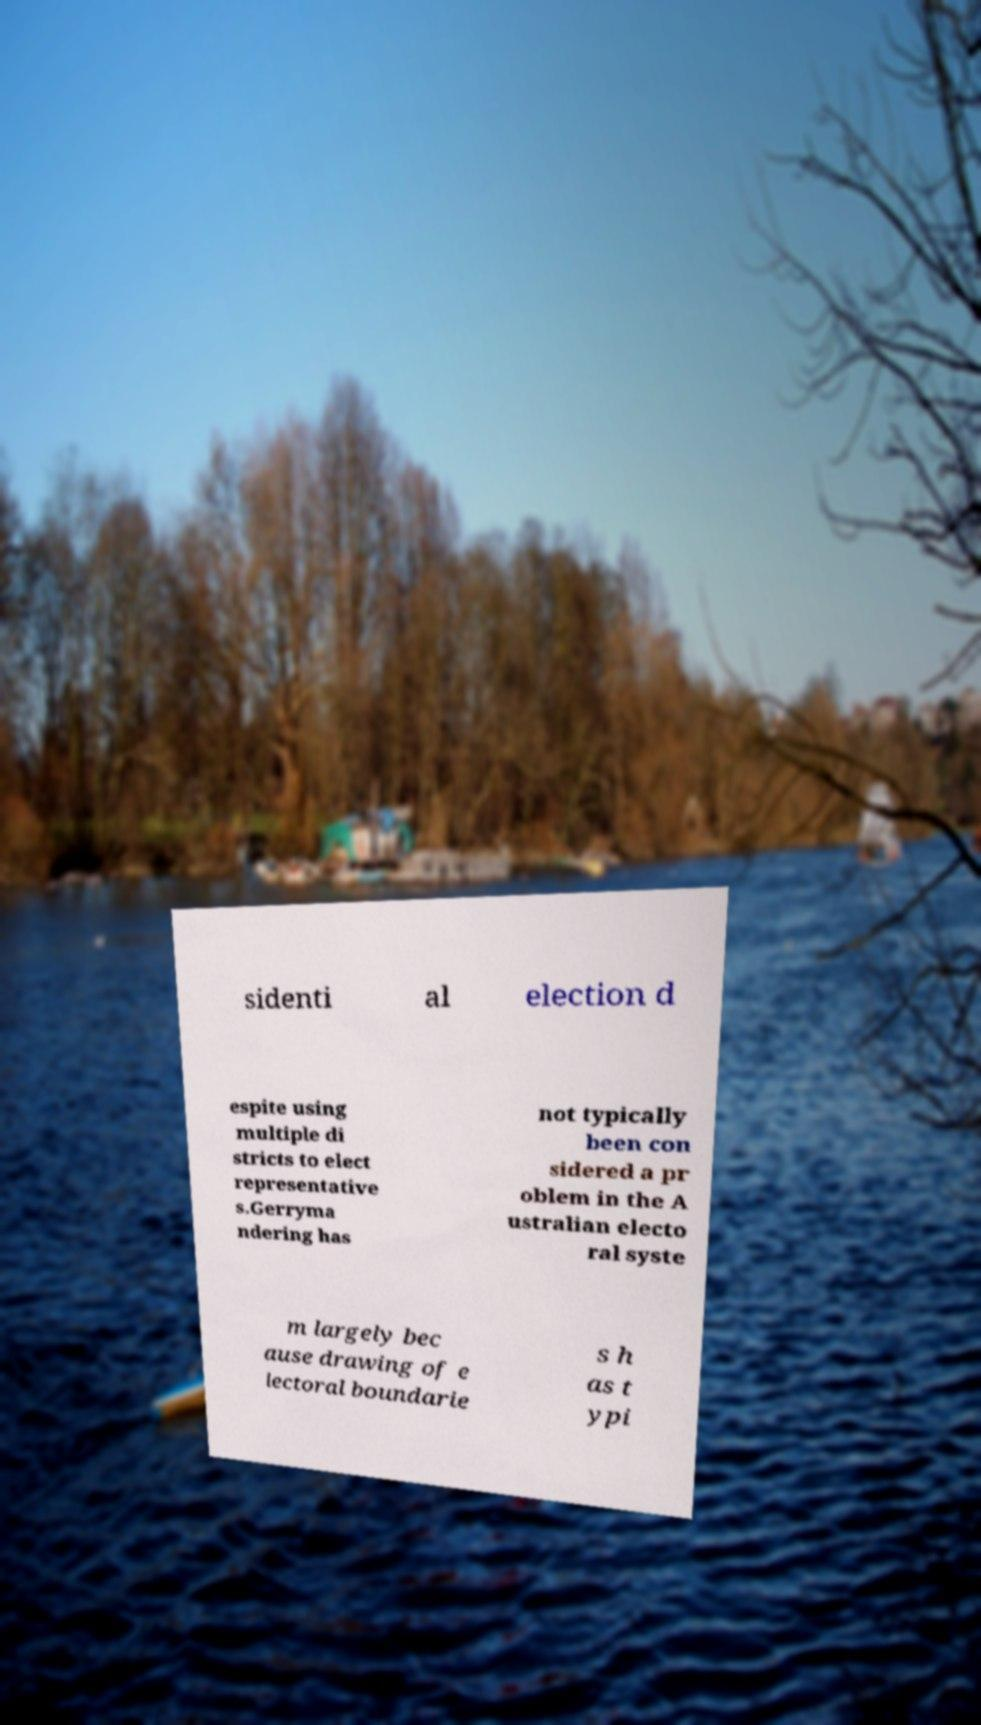Can you accurately transcribe the text from the provided image for me? sidenti al election d espite using multiple di stricts to elect representative s.Gerryma ndering has not typically been con sidered a pr oblem in the A ustralian electo ral syste m largely bec ause drawing of e lectoral boundarie s h as t ypi 